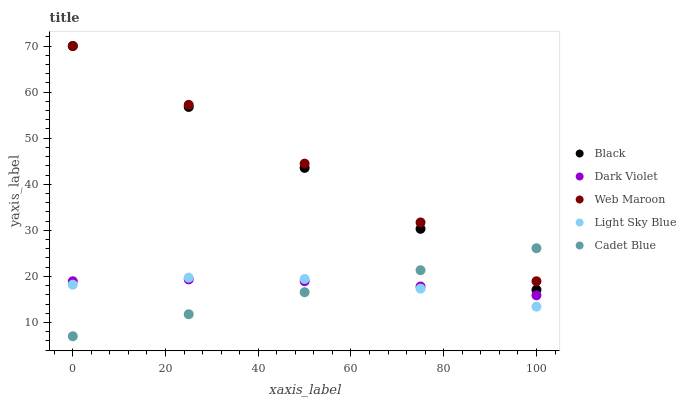Does Cadet Blue have the minimum area under the curve?
Answer yes or no. Yes. Does Web Maroon have the maximum area under the curve?
Answer yes or no. Yes. Does Light Sky Blue have the minimum area under the curve?
Answer yes or no. No. Does Light Sky Blue have the maximum area under the curve?
Answer yes or no. No. Is Cadet Blue the smoothest?
Answer yes or no. Yes. Is Light Sky Blue the roughest?
Answer yes or no. Yes. Is Web Maroon the smoothest?
Answer yes or no. No. Is Web Maroon the roughest?
Answer yes or no. No. Does Cadet Blue have the lowest value?
Answer yes or no. Yes. Does Light Sky Blue have the lowest value?
Answer yes or no. No. Does Black have the highest value?
Answer yes or no. Yes. Does Light Sky Blue have the highest value?
Answer yes or no. No. Is Light Sky Blue less than Black?
Answer yes or no. Yes. Is Web Maroon greater than Light Sky Blue?
Answer yes or no. Yes. Does Dark Violet intersect Cadet Blue?
Answer yes or no. Yes. Is Dark Violet less than Cadet Blue?
Answer yes or no. No. Is Dark Violet greater than Cadet Blue?
Answer yes or no. No. Does Light Sky Blue intersect Black?
Answer yes or no. No. 